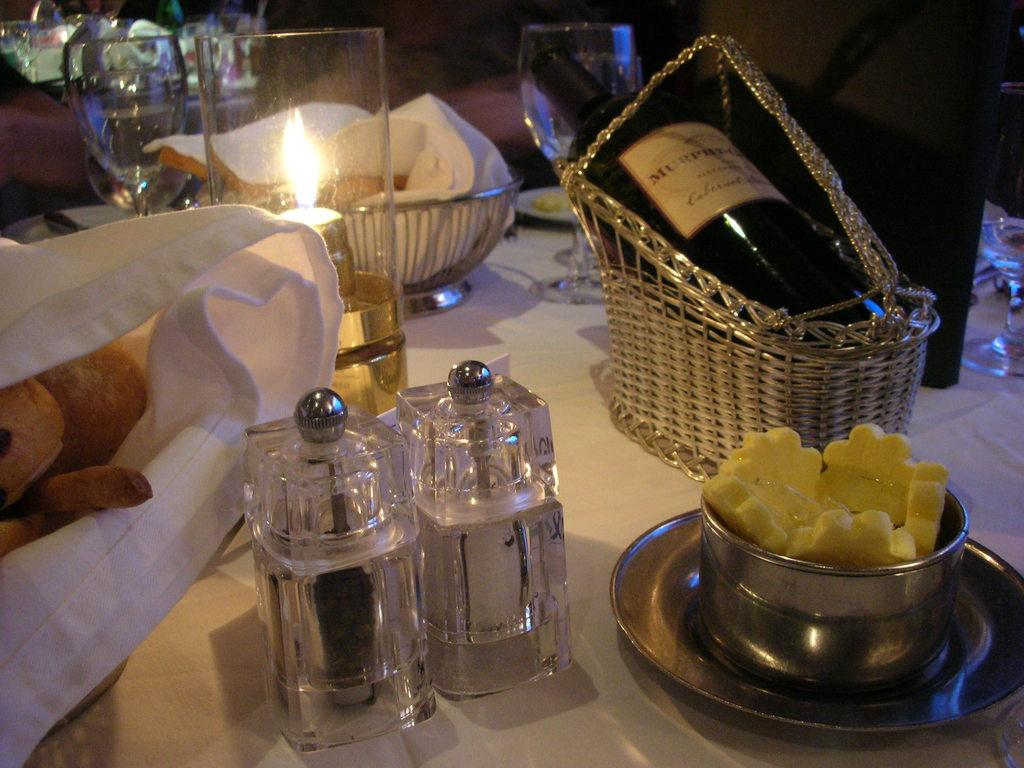What type of furniture is present in the image? There is a table in the image. What condiment containers can be seen on the table? There is a salt and pepper container on the table. What type of dishware is present on the table? There is a plate and a bowl on the table. What other items are on the table? There is a bottle, a basket, a candle, and a glass on the table. What can be inferred about the purpose of the table based on the items present? The table appears to be set for a meal, as there are food items on the table. What type of ring can be seen on the table in the image? There is no ring present on the table in the image. What type of fuel is being used to light the candle in the image? The image does not provide information about the type of fuel used for the candle. 